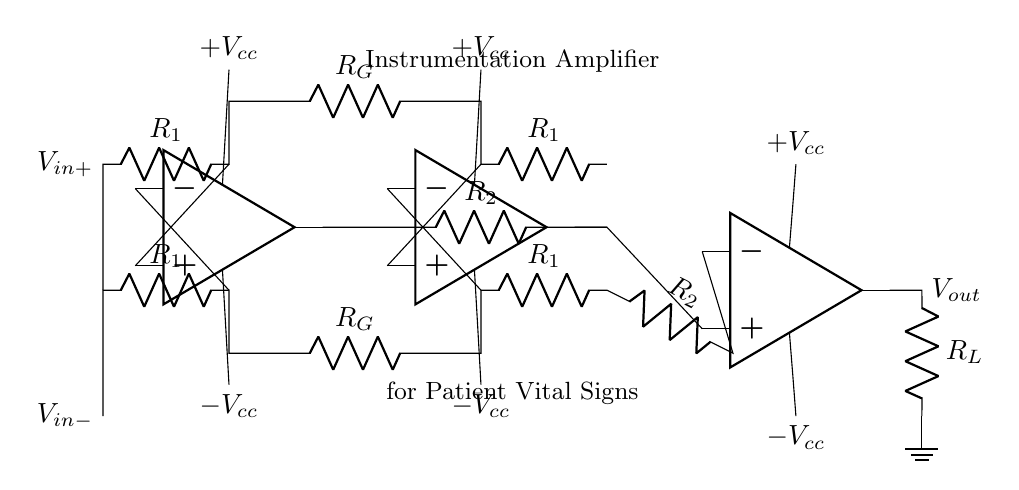What is the main function of this circuit? The main function is to amplify small differential signals to measure patient vital signs accurately during post-acute care. This is indicated by the labeling of the circuit and its components designed for precise signal processing.
Answer: Amplification of signals What type of amplifier is used in this circuit? The circuit employs an instrumentation amplifier, which is specifically designed to have high input impedance and low output impedance, making it ideal for measuring low-level signals from various sensors used in healthcare.
Answer: Instrumentation amplifier How many resistors are present in this circuit? There are six resistors labeled as R1, R2, and RG in the circuit diagram, where R1 is duplicated for both the non-inverting and inverting inputs, as well as R2 and RG.
Answer: Six resistors What does R_G control in an instrumentation amplifier? R_G controls the gain of the instrumentation amplifier, which is determined by its value and the resistors R1 and R2. This relationship allows for adjustment of the amplifier's sensitivity to the input signals.
Answer: Gain What is the output voltage denoted as in the circuit? The output voltage is denoted as V_out, which is the voltage available at the output of the final op-amp, representing the amplified signal after processing through the circuitry.
Answer: V_out What is the purpose of the ground in this circuit? The ground provides a reference point for the circuit, ensuring that the output voltage is measured correctly relative to a common return path. This is essential for accurate signal measurement and stability.
Answer: Reference point What is the role of the op-amps in the circuit? The op-amps serve to amplify the differential input voltage signals, processing the data received from the resistive network to provide a higher output signal that can be further analyzed or displayed.
Answer: Amplify signals 